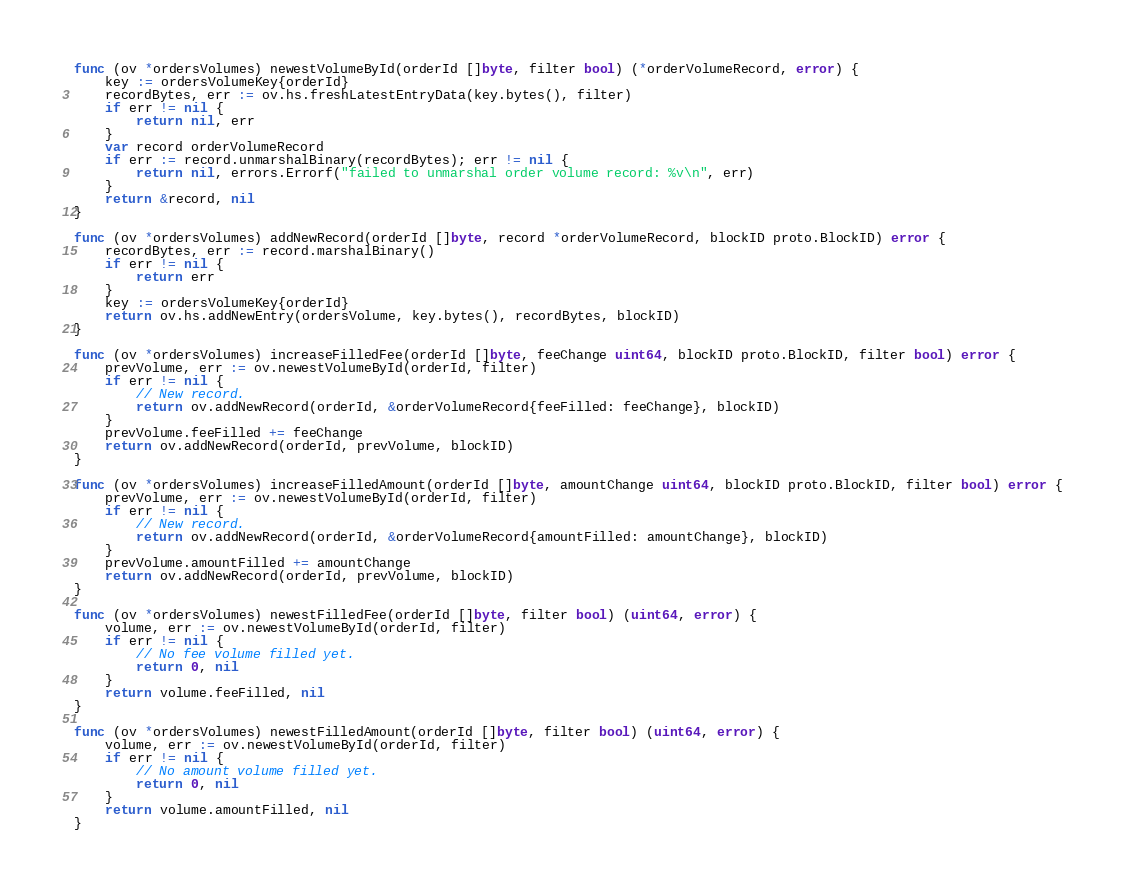Convert code to text. <code><loc_0><loc_0><loc_500><loc_500><_Go_>
func (ov *ordersVolumes) newestVolumeById(orderId []byte, filter bool) (*orderVolumeRecord, error) {
	key := ordersVolumeKey{orderId}
	recordBytes, err := ov.hs.freshLatestEntryData(key.bytes(), filter)
	if err != nil {
		return nil, err
	}
	var record orderVolumeRecord
	if err := record.unmarshalBinary(recordBytes); err != nil {
		return nil, errors.Errorf("failed to unmarshal order volume record: %v\n", err)
	}
	return &record, nil
}

func (ov *ordersVolumes) addNewRecord(orderId []byte, record *orderVolumeRecord, blockID proto.BlockID) error {
	recordBytes, err := record.marshalBinary()
	if err != nil {
		return err
	}
	key := ordersVolumeKey{orderId}
	return ov.hs.addNewEntry(ordersVolume, key.bytes(), recordBytes, blockID)
}

func (ov *ordersVolumes) increaseFilledFee(orderId []byte, feeChange uint64, blockID proto.BlockID, filter bool) error {
	prevVolume, err := ov.newestVolumeById(orderId, filter)
	if err != nil {
		// New record.
		return ov.addNewRecord(orderId, &orderVolumeRecord{feeFilled: feeChange}, blockID)
	}
	prevVolume.feeFilled += feeChange
	return ov.addNewRecord(orderId, prevVolume, blockID)
}

func (ov *ordersVolumes) increaseFilledAmount(orderId []byte, amountChange uint64, blockID proto.BlockID, filter bool) error {
	prevVolume, err := ov.newestVolumeById(orderId, filter)
	if err != nil {
		// New record.
		return ov.addNewRecord(orderId, &orderVolumeRecord{amountFilled: amountChange}, blockID)
	}
	prevVolume.amountFilled += amountChange
	return ov.addNewRecord(orderId, prevVolume, blockID)
}

func (ov *ordersVolumes) newestFilledFee(orderId []byte, filter bool) (uint64, error) {
	volume, err := ov.newestVolumeById(orderId, filter)
	if err != nil {
		// No fee volume filled yet.
		return 0, nil
	}
	return volume.feeFilled, nil
}

func (ov *ordersVolumes) newestFilledAmount(orderId []byte, filter bool) (uint64, error) {
	volume, err := ov.newestVolumeById(orderId, filter)
	if err != nil {
		// No amount volume filled yet.
		return 0, nil
	}
	return volume.amountFilled, nil
}
</code> 